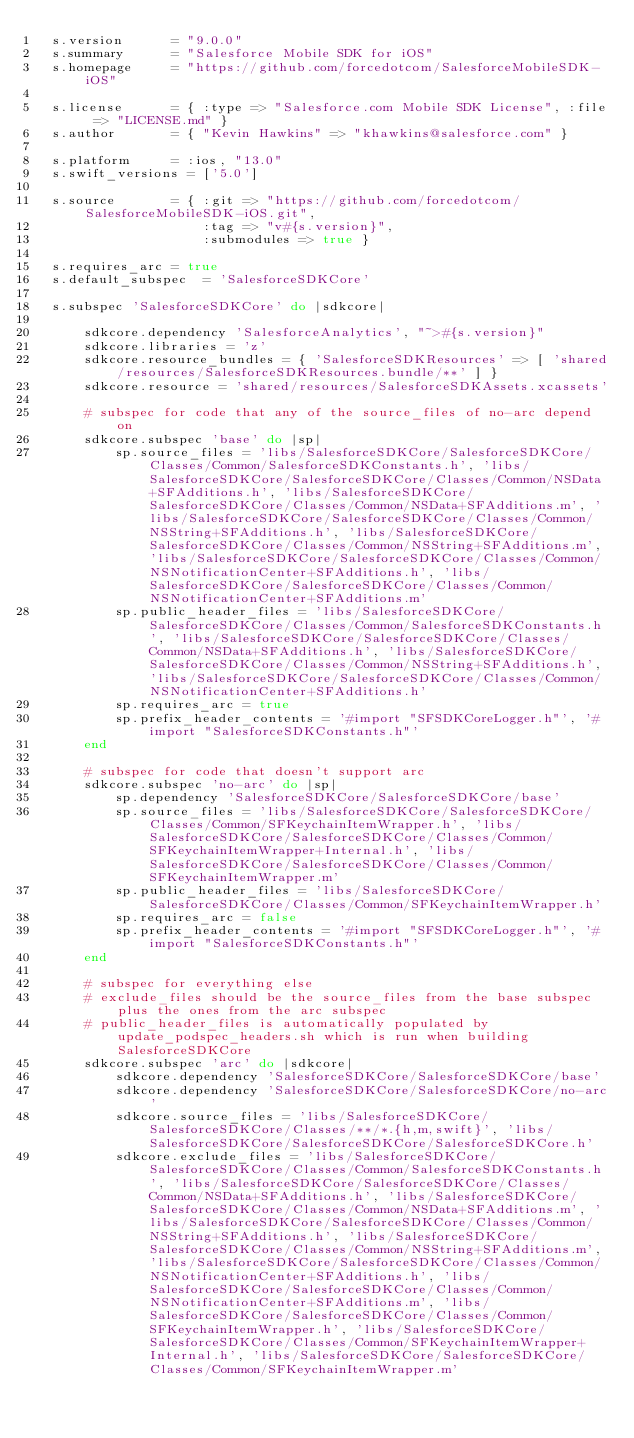<code> <loc_0><loc_0><loc_500><loc_500><_Ruby_>  s.version      = "9.0.0"
  s.summary      = "Salesforce Mobile SDK for iOS"
  s.homepage     = "https://github.com/forcedotcom/SalesforceMobileSDK-iOS"

  s.license      = { :type => "Salesforce.com Mobile SDK License", :file => "LICENSE.md" }
  s.author       = { "Kevin Hawkins" => "khawkins@salesforce.com" }

  s.platform     = :ios, "13.0"
  s.swift_versions = ['5.0']

  s.source       = { :git => "https://github.com/forcedotcom/SalesforceMobileSDK-iOS.git",
                     :tag => "v#{s.version}",
                     :submodules => true }

  s.requires_arc = true
  s.default_subspec  = 'SalesforceSDKCore'

  s.subspec 'SalesforceSDKCore' do |sdkcore|

      sdkcore.dependency 'SalesforceAnalytics', "~>#{s.version}"
      sdkcore.libraries = 'z'
      sdkcore.resource_bundles = { 'SalesforceSDKResources' => [ 'shared/resources/SalesforceSDKResources.bundle/**' ] }
      sdkcore.resource = 'shared/resources/SalesforceSDKAssets.xcassets'

      # subspec for code that any of the source_files of no-arc depend on
      sdkcore.subspec 'base' do |sp|
          sp.source_files = 'libs/SalesforceSDKCore/SalesforceSDKCore/Classes/Common/SalesforceSDKConstants.h', 'libs/SalesforceSDKCore/SalesforceSDKCore/Classes/Common/NSData+SFAdditions.h', 'libs/SalesforceSDKCore/SalesforceSDKCore/Classes/Common/NSData+SFAdditions.m', 'libs/SalesforceSDKCore/SalesforceSDKCore/Classes/Common/NSString+SFAdditions.h', 'libs/SalesforceSDKCore/SalesforceSDKCore/Classes/Common/NSString+SFAdditions.m','libs/SalesforceSDKCore/SalesforceSDKCore/Classes/Common/NSNotificationCenter+SFAdditions.h', 'libs/SalesforceSDKCore/SalesforceSDKCore/Classes/Common/NSNotificationCenter+SFAdditions.m'
          sp.public_header_files = 'libs/SalesforceSDKCore/SalesforceSDKCore/Classes/Common/SalesforceSDKConstants.h', 'libs/SalesforceSDKCore/SalesforceSDKCore/Classes/Common/NSData+SFAdditions.h', 'libs/SalesforceSDKCore/SalesforceSDKCore/Classes/Common/NSString+SFAdditions.h','libs/SalesforceSDKCore/SalesforceSDKCore/Classes/Common/NSNotificationCenter+SFAdditions.h'
          sp.requires_arc = true
          sp.prefix_header_contents = '#import "SFSDKCoreLogger.h"', '#import "SalesforceSDKConstants.h"'
      end

      # subspec for code that doesn't support arc
      sdkcore.subspec 'no-arc' do |sp|
          sp.dependency 'SalesforceSDKCore/SalesforceSDKCore/base'
          sp.source_files = 'libs/SalesforceSDKCore/SalesforceSDKCore/Classes/Common/SFKeychainItemWrapper.h', 'libs/SalesforceSDKCore/SalesforceSDKCore/Classes/Common/SFKeychainItemWrapper+Internal.h', 'libs/SalesforceSDKCore/SalesforceSDKCore/Classes/Common/SFKeychainItemWrapper.m'
          sp.public_header_files = 'libs/SalesforceSDKCore/SalesforceSDKCore/Classes/Common/SFKeychainItemWrapper.h'
          sp.requires_arc = false
          sp.prefix_header_contents = '#import "SFSDKCoreLogger.h"', '#import "SalesforceSDKConstants.h"'
      end

      # subspec for everything else
      # exclude_files should be the source_files from the base subspec plus the ones from the arc subspec
      # public_header_files is automatically populated by update_podspec_headers.sh which is run when building SalesforceSDKCore
      sdkcore.subspec 'arc' do |sdkcore|
          sdkcore.dependency 'SalesforceSDKCore/SalesforceSDKCore/base'
          sdkcore.dependency 'SalesforceSDKCore/SalesforceSDKCore/no-arc'
          sdkcore.source_files = 'libs/SalesforceSDKCore/SalesforceSDKCore/Classes/**/*.{h,m,swift}', 'libs/SalesforceSDKCore/SalesforceSDKCore/SalesforceSDKCore.h'
          sdkcore.exclude_files = 'libs/SalesforceSDKCore/SalesforceSDKCore/Classes/Common/SalesforceSDKConstants.h', 'libs/SalesforceSDKCore/SalesforceSDKCore/Classes/Common/NSData+SFAdditions.h', 'libs/SalesforceSDKCore/SalesforceSDKCore/Classes/Common/NSData+SFAdditions.m', 'libs/SalesforceSDKCore/SalesforceSDKCore/Classes/Common/NSString+SFAdditions.h', 'libs/SalesforceSDKCore/SalesforceSDKCore/Classes/Common/NSString+SFAdditions.m','libs/SalesforceSDKCore/SalesforceSDKCore/Classes/Common/NSNotificationCenter+SFAdditions.h', 'libs/SalesforceSDKCore/SalesforceSDKCore/Classes/Common/NSNotificationCenter+SFAdditions.m', 'libs/SalesforceSDKCore/SalesforceSDKCore/Classes/Common/SFKeychainItemWrapper.h', 'libs/SalesforceSDKCore/SalesforceSDKCore/Classes/Common/SFKeychainItemWrapper+Internal.h', 'libs/SalesforceSDKCore/SalesforceSDKCore/Classes/Common/SFKeychainItemWrapper.m'</code> 